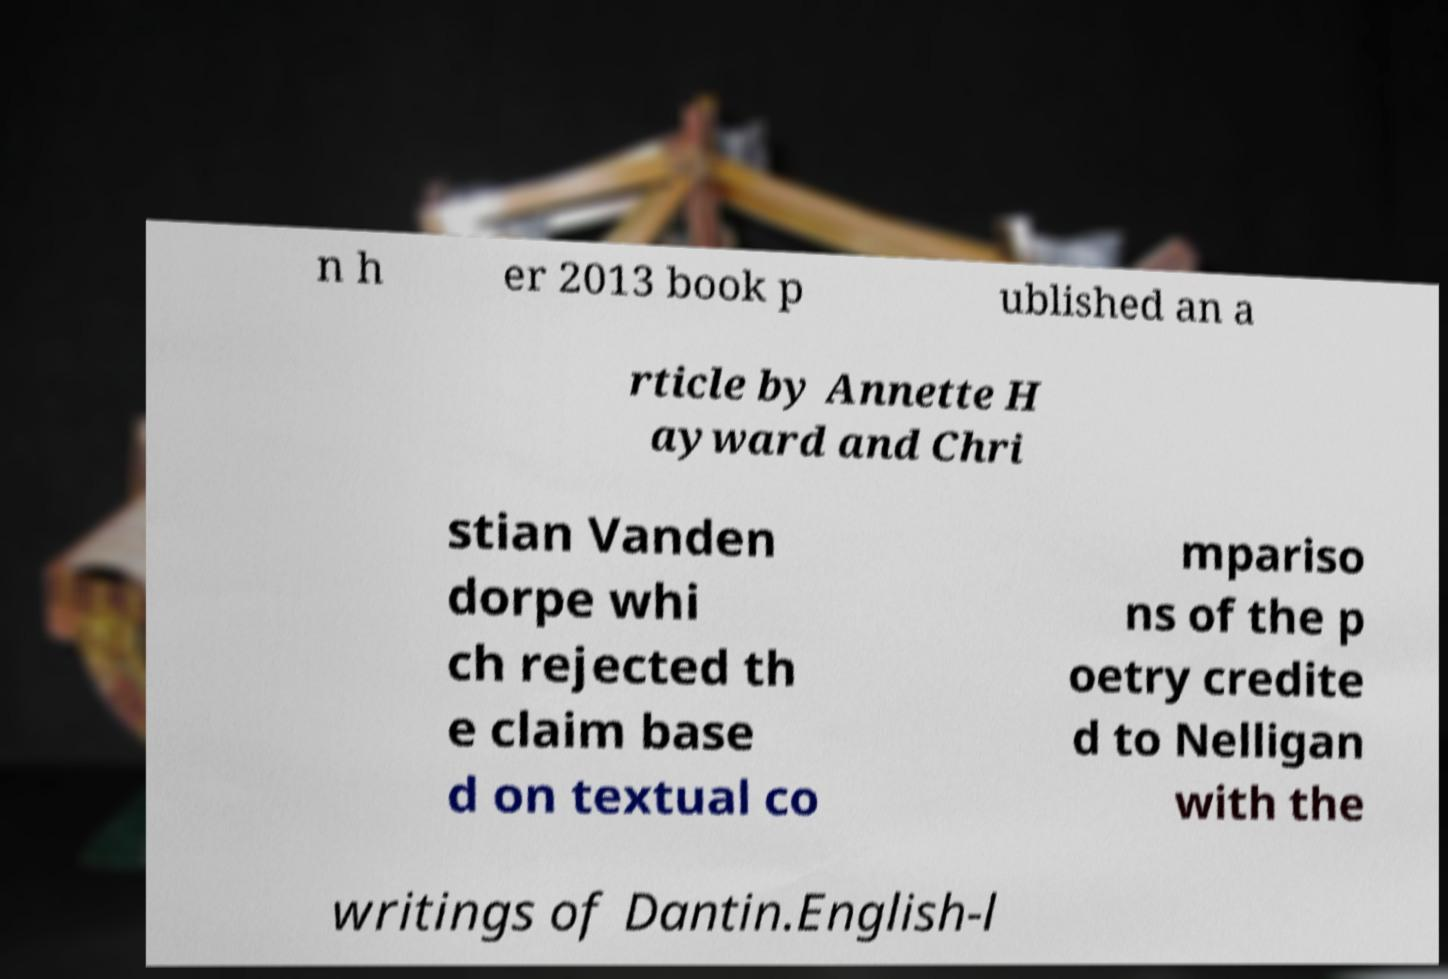There's text embedded in this image that I need extracted. Can you transcribe it verbatim? n h er 2013 book p ublished an a rticle by Annette H ayward and Chri stian Vanden dorpe whi ch rejected th e claim base d on textual co mpariso ns of the p oetry credite d to Nelligan with the writings of Dantin.English-l 